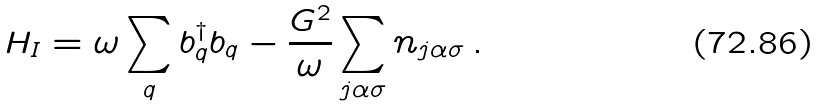Convert formula to latex. <formula><loc_0><loc_0><loc_500><loc_500>H _ { I } = \omega \sum _ { q } b ^ { \dag } _ { q } b _ { q } - \frac { G ^ { 2 } } { \omega } \sum _ { j \alpha \sigma } n _ { j \alpha \sigma } \, .</formula> 